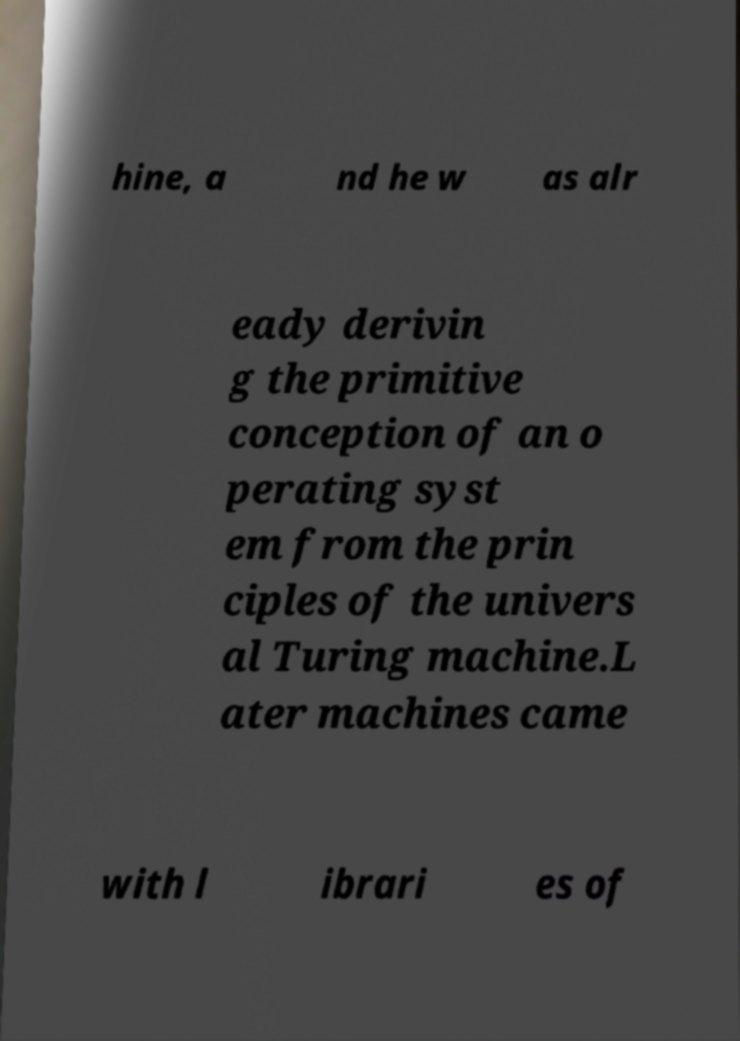I need the written content from this picture converted into text. Can you do that? hine, a nd he w as alr eady derivin g the primitive conception of an o perating syst em from the prin ciples of the univers al Turing machine.L ater machines came with l ibrari es of 